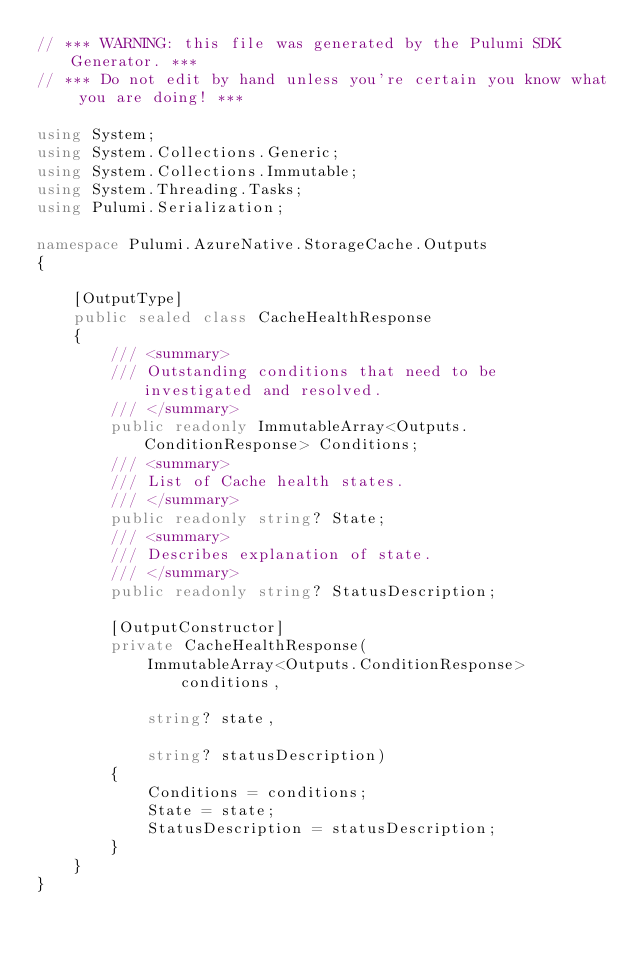Convert code to text. <code><loc_0><loc_0><loc_500><loc_500><_C#_>// *** WARNING: this file was generated by the Pulumi SDK Generator. ***
// *** Do not edit by hand unless you're certain you know what you are doing! ***

using System;
using System.Collections.Generic;
using System.Collections.Immutable;
using System.Threading.Tasks;
using Pulumi.Serialization;

namespace Pulumi.AzureNative.StorageCache.Outputs
{

    [OutputType]
    public sealed class CacheHealthResponse
    {
        /// <summary>
        /// Outstanding conditions that need to be investigated and resolved.
        /// </summary>
        public readonly ImmutableArray<Outputs.ConditionResponse> Conditions;
        /// <summary>
        /// List of Cache health states.
        /// </summary>
        public readonly string? State;
        /// <summary>
        /// Describes explanation of state.
        /// </summary>
        public readonly string? StatusDescription;

        [OutputConstructor]
        private CacheHealthResponse(
            ImmutableArray<Outputs.ConditionResponse> conditions,

            string? state,

            string? statusDescription)
        {
            Conditions = conditions;
            State = state;
            StatusDescription = statusDescription;
        }
    }
}
</code> 